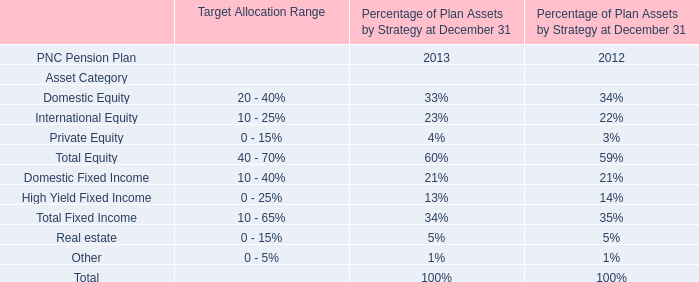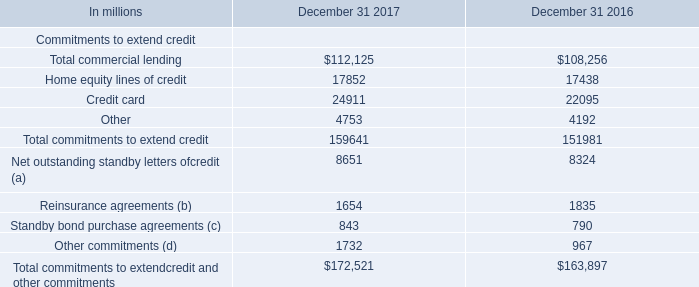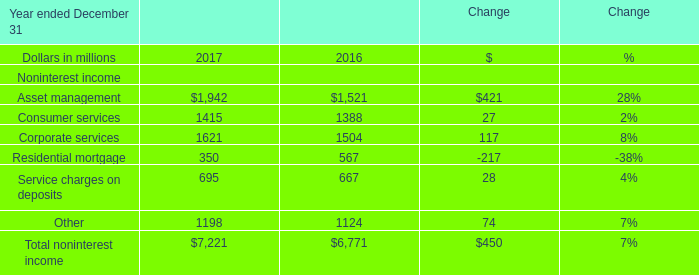What is the average amount of Home equity lines of credit of December 31 2016, and Consumer services of Change 2016 ? 
Computations: ((17438.0 + 1388.0) / 2)
Answer: 9413.0. 